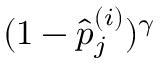Convert formula to latex. <formula><loc_0><loc_0><loc_500><loc_500>( 1 - \hat { p } _ { j } ^ { ( i ) } ) ^ { \gamma }</formula> 